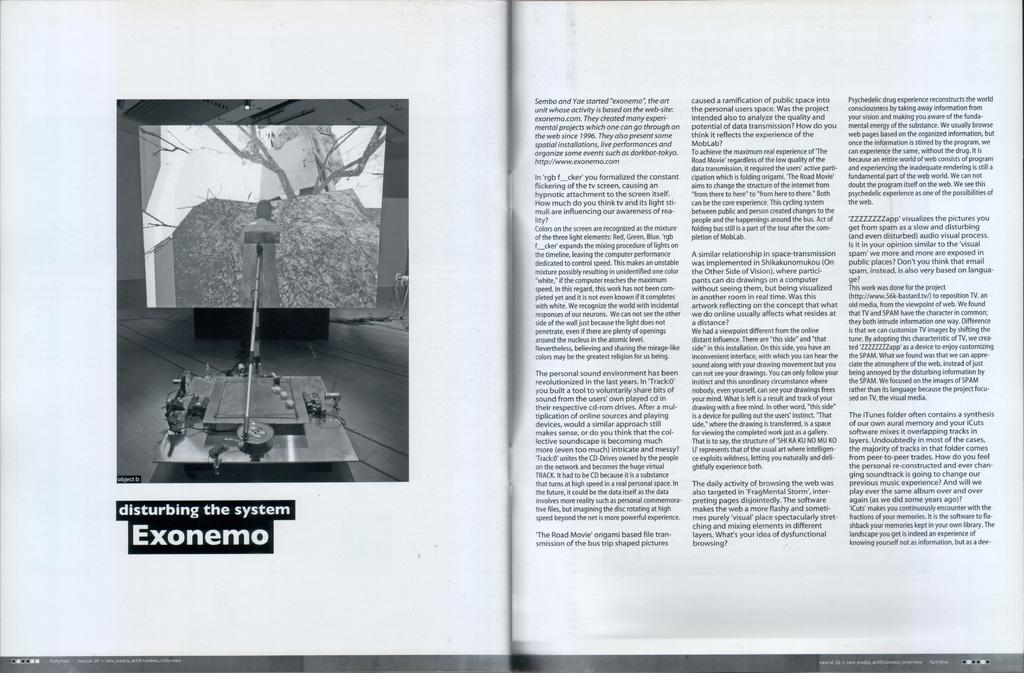Provide a one-sentence caption for the provided image. a book that is opened with a reference to EXONEMO. 